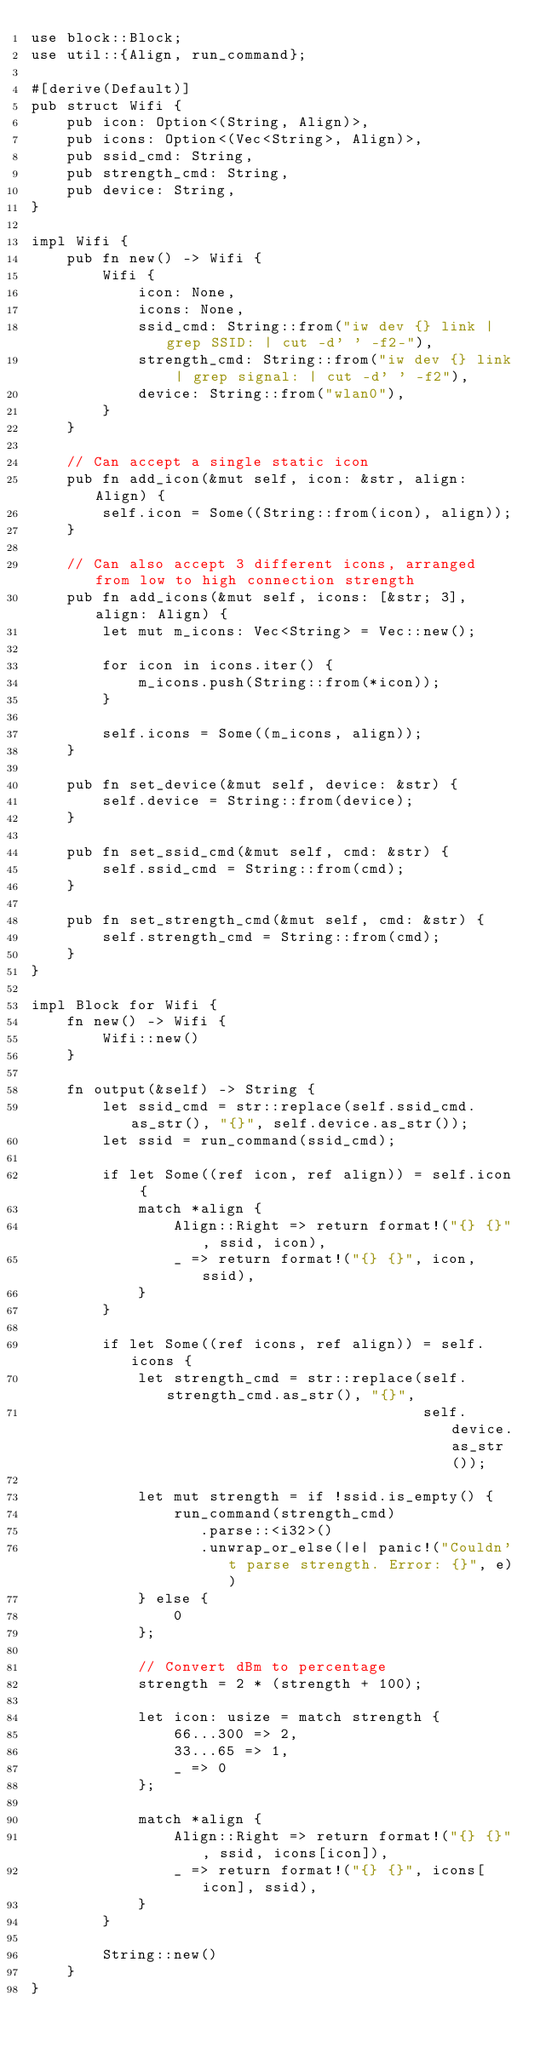<code> <loc_0><loc_0><loc_500><loc_500><_Rust_>use block::Block;
use util::{Align, run_command};

#[derive(Default)]
pub struct Wifi {
    pub icon: Option<(String, Align)>,
    pub icons: Option<(Vec<String>, Align)>,
    pub ssid_cmd: String,
    pub strength_cmd: String,
    pub device: String,
}

impl Wifi {
    pub fn new() -> Wifi {
        Wifi {
            icon: None,
            icons: None,
            ssid_cmd: String::from("iw dev {} link | grep SSID: | cut -d' ' -f2-"),
            strength_cmd: String::from("iw dev {} link | grep signal: | cut -d' ' -f2"),
            device: String::from("wlan0"),
        }
    }

    // Can accept a single static icon
    pub fn add_icon(&mut self, icon: &str, align: Align) {
        self.icon = Some((String::from(icon), align));
    }

    // Can also accept 3 different icons, arranged from low to high connection strength
    pub fn add_icons(&mut self, icons: [&str; 3], align: Align) {
        let mut m_icons: Vec<String> = Vec::new();

        for icon in icons.iter() {
            m_icons.push(String::from(*icon));
        }

        self.icons = Some((m_icons, align));
    }

    pub fn set_device(&mut self, device: &str) {
        self.device = String::from(device);
    }

    pub fn set_ssid_cmd(&mut self, cmd: &str) {
        self.ssid_cmd = String::from(cmd);
    }

    pub fn set_strength_cmd(&mut self, cmd: &str) {
        self.strength_cmd = String::from(cmd);
    }
}

impl Block for Wifi {
    fn new() -> Wifi {
        Wifi::new()
    }

    fn output(&self) -> String {
        let ssid_cmd = str::replace(self.ssid_cmd.as_str(), "{}", self.device.as_str());
        let ssid = run_command(ssid_cmd);

        if let Some((ref icon, ref align)) = self.icon {
            match *align {
                Align::Right => return format!("{} {}", ssid, icon),
                _ => return format!("{} {}", icon, ssid),
            }
        }

        if let Some((ref icons, ref align)) = self.icons {
            let strength_cmd = str::replace(self.strength_cmd.as_str(), "{}",
                                            self.device.as_str());

            let mut strength = if !ssid.is_empty() {
                run_command(strength_cmd)
                   .parse::<i32>()
                   .unwrap_or_else(|e| panic!("Couldn't parse strength. Error: {}", e))
            } else {
                0
            };

            // Convert dBm to percentage
            strength = 2 * (strength + 100);

            let icon: usize = match strength {
                66...300 => 2,
                33...65 => 1,
                _ => 0
            };

            match *align {
                Align::Right => return format!("{} {}", ssid, icons[icon]),
                _ => return format!("{} {}", icons[icon], ssid),
            }
        }

        String::new()
    }
}
</code> 